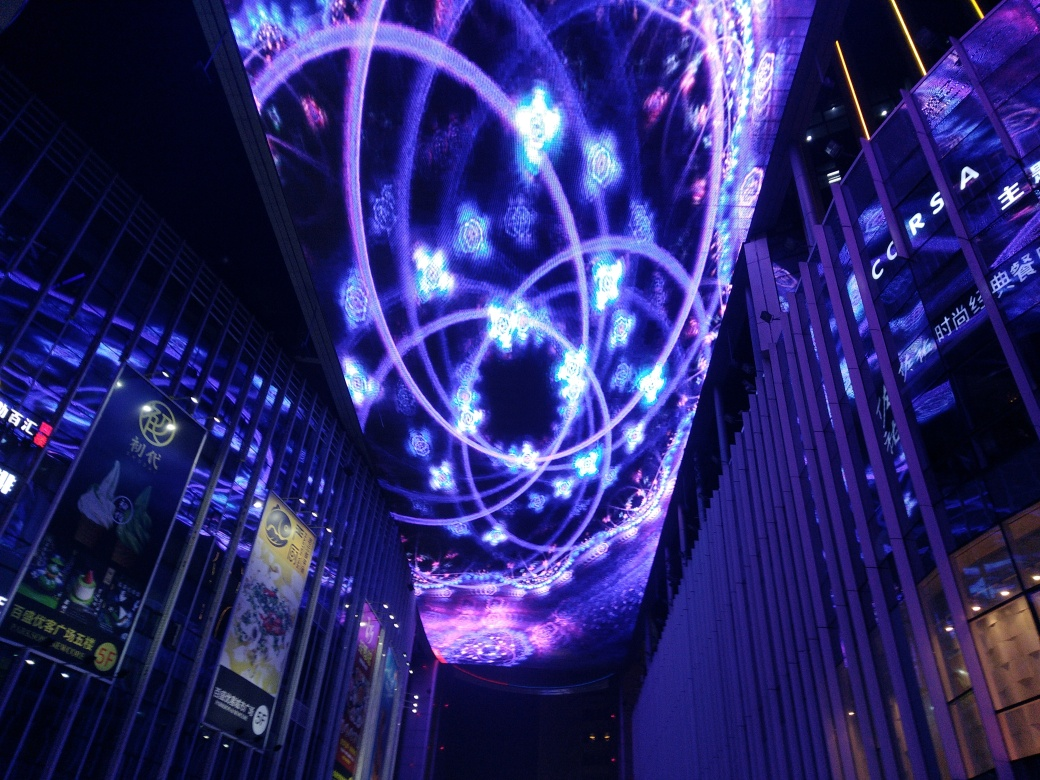What time of day does this image portray, and how can you tell? The image portrays nighttime, as evidenced by the dark sky contrasting with the luminous displays. The lights stand out sharply against the backdrop, which is a common characteristic of evening or night settings in urban environments. 